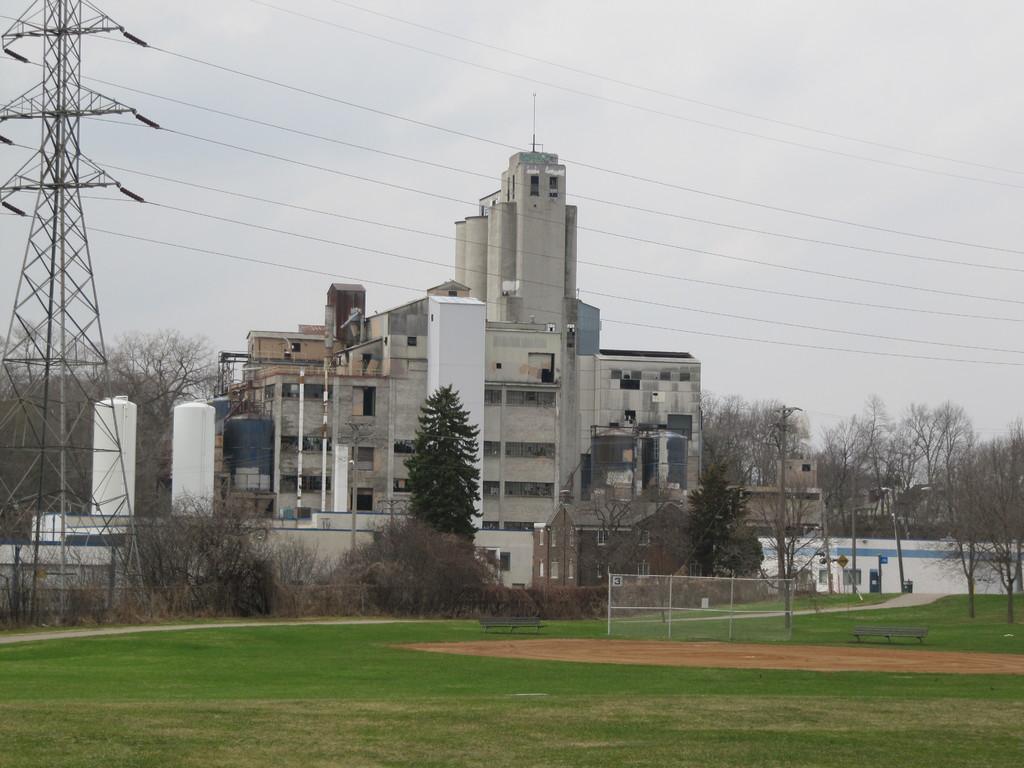In one or two sentences, can you explain what this image depicts? The picture is clicked outside. In the foreground we can see the green grass. In the center we can see the mesh, metal rods, bench, trees, dry stems and branches of the trees. On the left we can see a pole, and in the center we can see the cables and the buildings and some objects which seems to be the towers. In the background we can see the sky, buildings and the trees. 